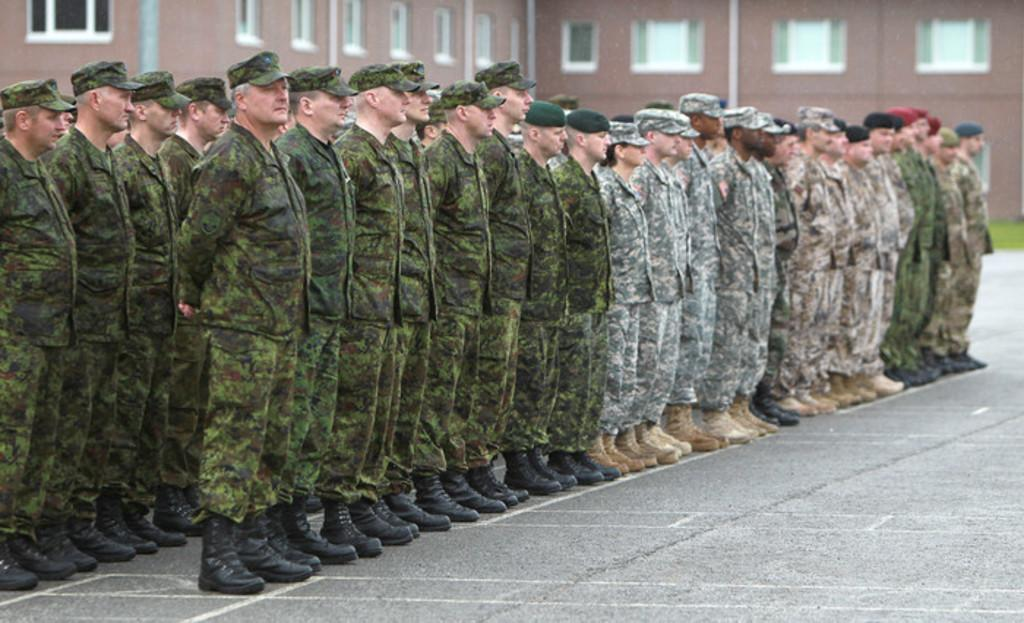What are the men in the image doing? The men in the image are standing in rows. Where are the men standing in the image? The men are standing on the floor. What can be seen in the background of the image? There are buildings, windows, and the ground visible in the background of the image. What is the name of the opinion expressed by the men in the image? There is no opinion expressed by the men in the image, as they are simply standing in rows. 